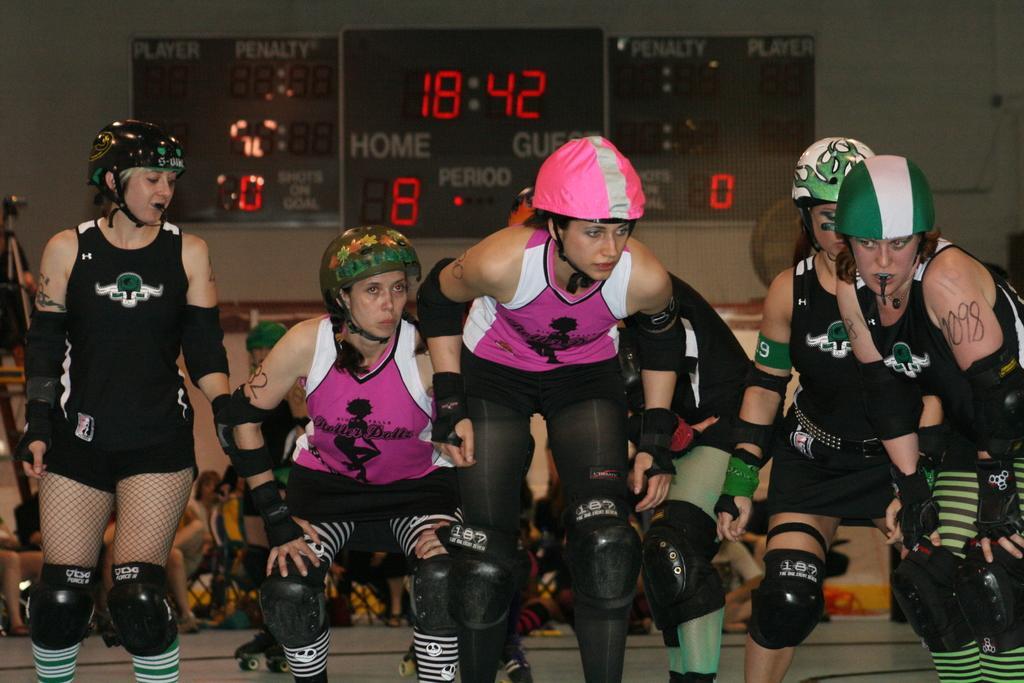In one or two sentences, can you explain what this image depicts? In this image in the center there are a group of people who are wearing helmets and knee caps, and it seems that they are doing something. In the background there are boards, on the boards there is text and there is wall and objects. At the bottom there is floor. 